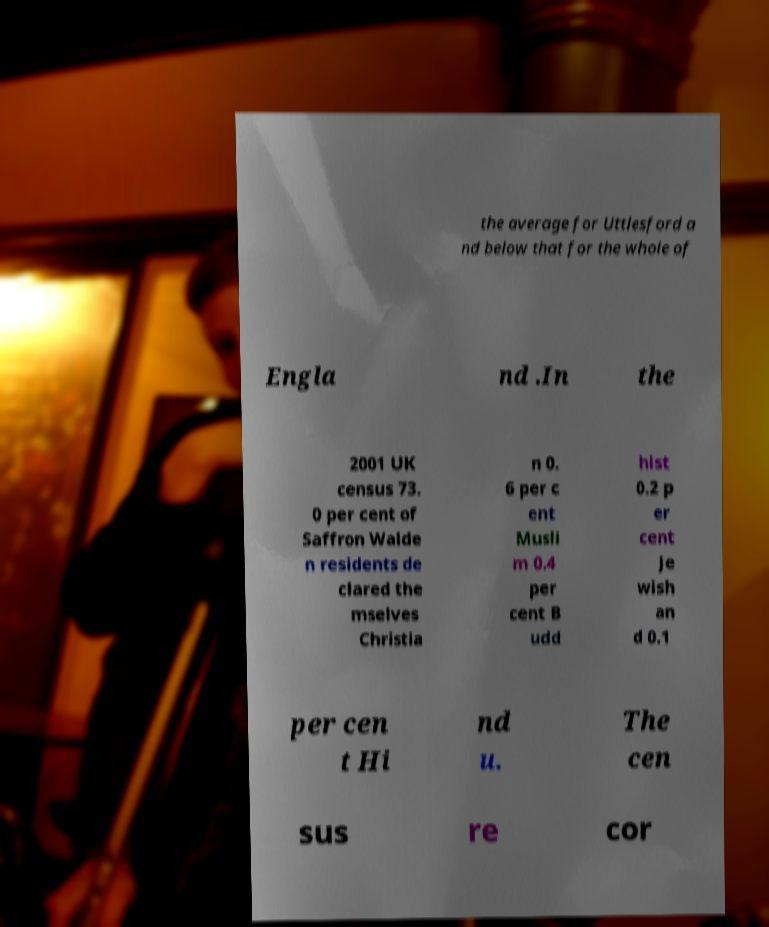For documentation purposes, I need the text within this image transcribed. Could you provide that? the average for Uttlesford a nd below that for the whole of Engla nd .In the 2001 UK census 73. 0 per cent of Saffron Walde n residents de clared the mselves Christia n 0. 6 per c ent Musli m 0.4 per cent B udd hist 0.2 p er cent Je wish an d 0.1 per cen t Hi nd u. The cen sus re cor 